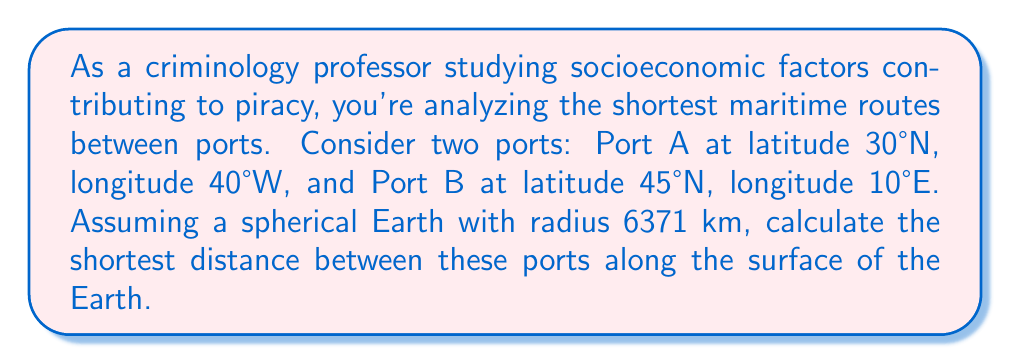Can you answer this question? To solve this problem, we'll use the great circle distance formula, which gives the shortest path between two points on a sphere. The steps are as follows:

1. Convert the latitudes and longitudes to radians:
   Port A: $\phi_1 = 30° \cdot \frac{\pi}{180} = \frac{\pi}{6}$, $\lambda_1 = -40° \cdot \frac{\pi}{180} = -\frac{2\pi}{9}$
   Port B: $\phi_2 = 45° \cdot \frac{\pi}{180} = \frac{\pi}{4}$, $\lambda_2 = 10° \cdot \frac{\pi}{180} = \frac{\pi}{18}$

2. Calculate the central angle $\Delta\sigma$ using the Haversine formula:
   $$\Delta\sigma = 2 \arcsin\left(\sqrt{\sin^2\left(\frac{\phi_2 - \phi_1}{2}\right) + \cos\phi_1 \cos\phi_2 \sin^2\left(\frac{\lambda_2 - \lambda_1}{2}\right)}\right)$$

3. Substitute the values:
   $$\Delta\sigma = 2 \arcsin\left(\sqrt{\sin^2\left(\frac{\frac{\pi}{4} - \frac{\pi}{6}}{2}\right) + \cos\frac{\pi}{6} \cos\frac{\pi}{4} \sin^2\left(\frac{\frac{\pi}{18} - (-\frac{2\pi}{9})}{2}\right)}\right)$$

4. Simplify and calculate:
   $$\Delta\sigma \approx 1.0996 \text{ radians}$$

5. Calculate the distance $d$ using the formula $d = R\Delta\sigma$, where $R$ is the Earth's radius:
   $$d = 6371 \cdot 1.0996 \approx 7005.5 \text{ km}$$

This distance represents the shortest path between the two ports along the surface of the spherical Earth model.

[asy]
import geometry;

size(200);
draw(Circle((0,0),1));
pair A = dir(60);
pair B = dir(135);
draw(A--B,red);
dot("A",A,SE);
dot("B",B,NW);
label("Equator",(1,0),E);
label("Prime Meridian",(0,1),N);
[/asy]
Answer: 7005.5 km 